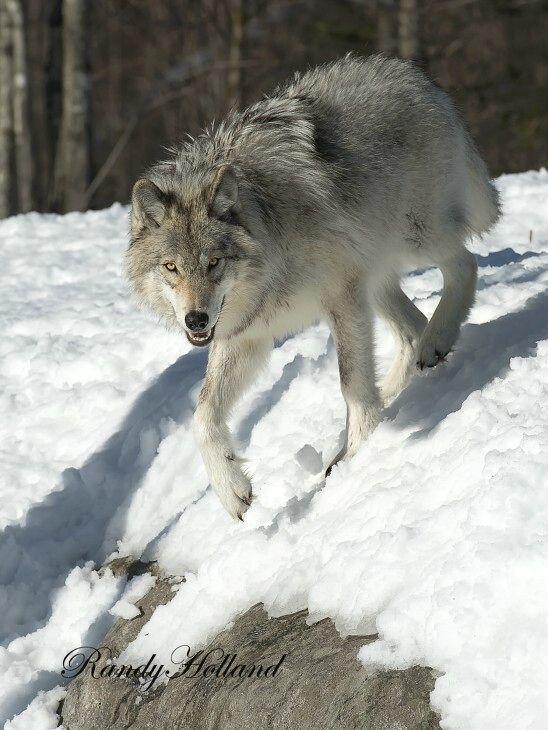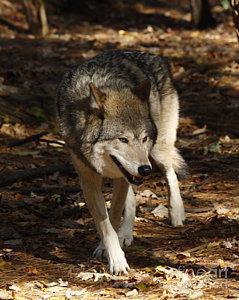The first image is the image on the left, the second image is the image on the right. For the images displayed, is the sentence "All of the images show a wolf in a standing position." factually correct? Answer yes or no. Yes. The first image is the image on the left, the second image is the image on the right. Considering the images on both sides, is "In the image of the wolf on the right, it appears to be autumn." valid? Answer yes or no. Yes. 